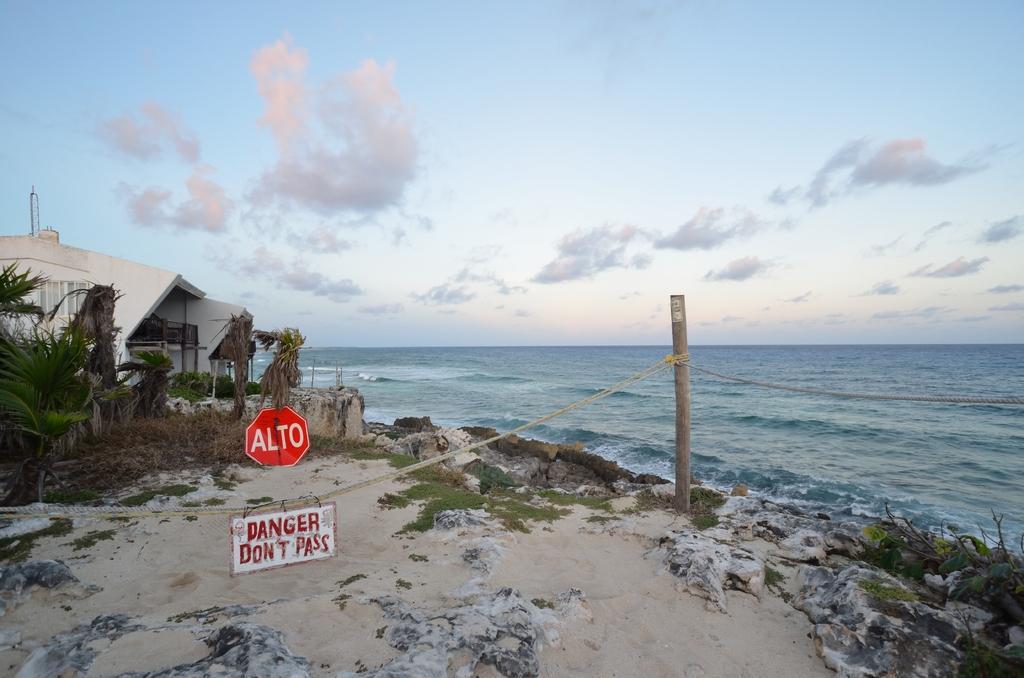In one or two sentences, can you explain what this image depicts? In this picture we can see signboard on a rope which is tied to the pole. There is another signboard on the ground. We can see few plants and a building on left side. We can see some waves in water. Sky is cloudy. 